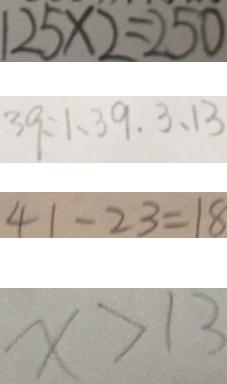<formula> <loc_0><loc_0><loc_500><loc_500>1 2 5 \times 2 = 2 5 0 
 3 9 : 1 、 3 9 . 3 、 1 3 
 4 1 - 2 3 = 1 8 
 X > 1 3</formula> 